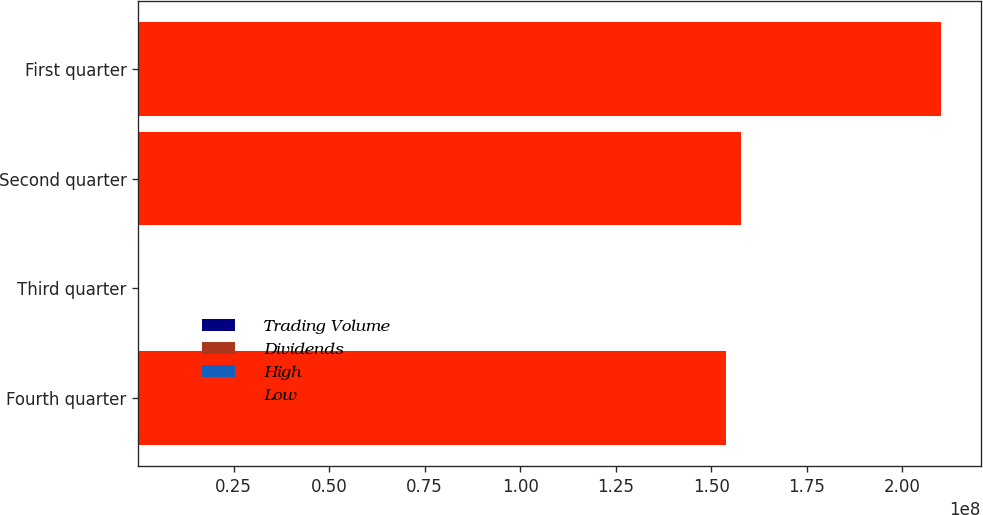<chart> <loc_0><loc_0><loc_500><loc_500><stacked_bar_chart><ecel><fcel>Fourth quarter<fcel>Third quarter<fcel>Second quarter<fcel>First quarter<nl><fcel>Trading Volume<fcel>52.3<fcel>54.73<fcel>43.71<fcel>45.05<nl><fcel>Dividends<fcel>39<fcel>42.68<fcel>35.89<fcel>30.15<nl><fcel>High<fcel>0.33<fcel>0.33<fcel>0.33<fcel>0.32<nl><fcel>Low<fcel>1.53989e+08<fcel>42.68<fcel>1.57763e+08<fcel>2.10069e+08<nl></chart> 